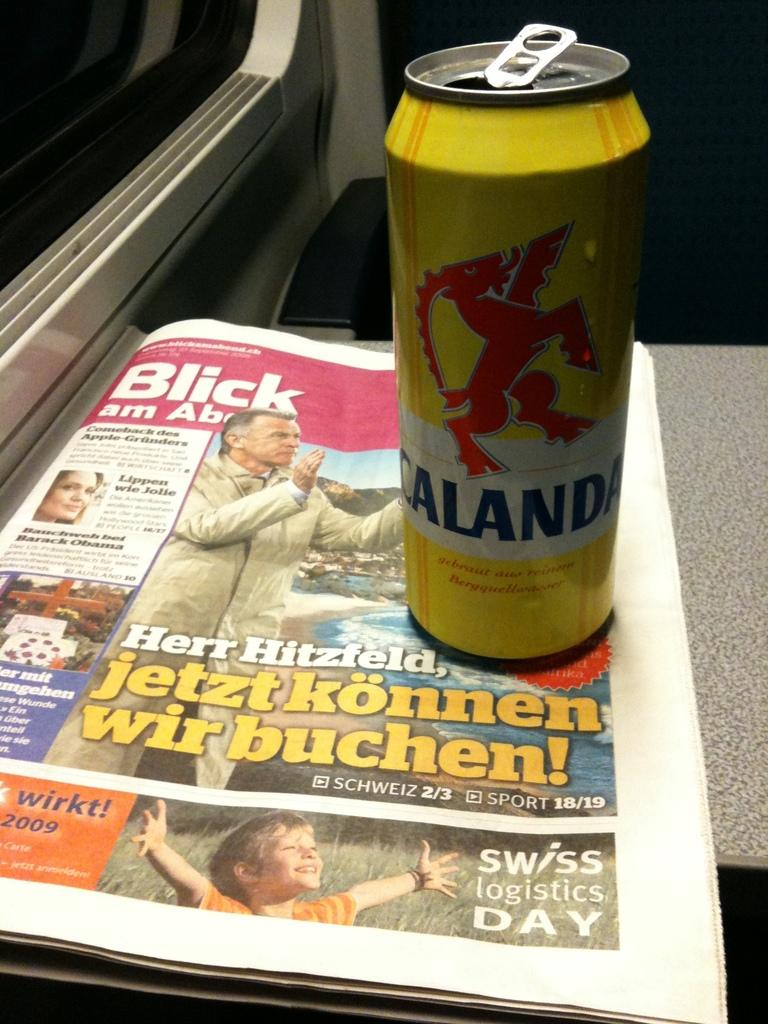<image>
Share a concise interpretation of the image provided. a Calanda yellow can on a Blick Am Abend newspaper 